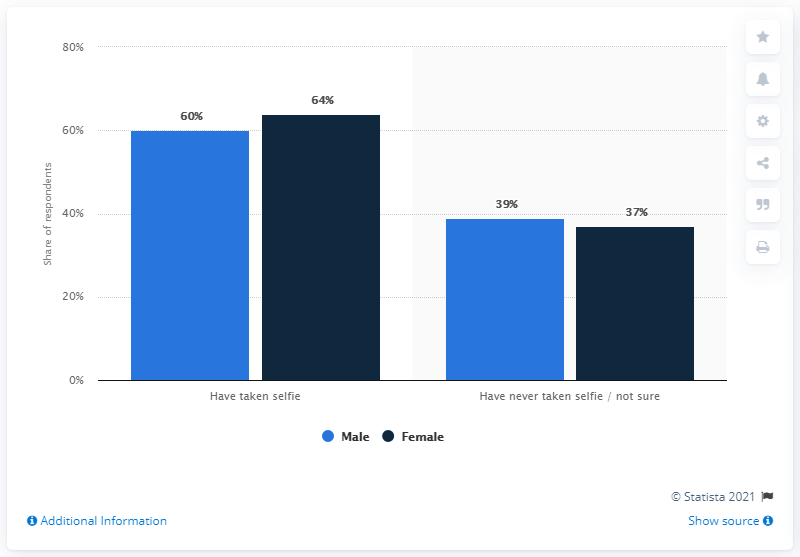Draw attention to some important aspects in this diagram. According to a recent survey, the majority of adults who have taken the most selfies are female. 